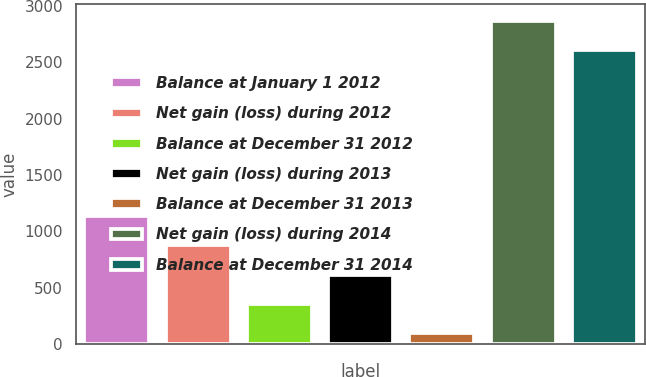<chart> <loc_0><loc_0><loc_500><loc_500><bar_chart><fcel>Balance at January 1 2012<fcel>Net gain (loss) during 2012<fcel>Balance at December 31 2012<fcel>Net gain (loss) during 2013<fcel>Balance at December 31 2013<fcel>Net gain (loss) during 2014<fcel>Balance at December 31 2014<nl><fcel>1139.4<fcel>878.8<fcel>357.6<fcel>618.2<fcel>97<fcel>2866.6<fcel>2606<nl></chart> 